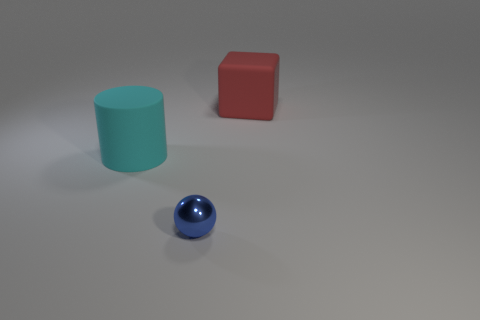Add 3 purple rubber cylinders. How many objects exist? 6 Subtract all cylinders. How many objects are left? 2 Subtract 1 cyan cylinders. How many objects are left? 2 Subtract all big rubber blocks. Subtract all red cubes. How many objects are left? 1 Add 1 cylinders. How many cylinders are left? 2 Add 1 cyan rubber things. How many cyan rubber things exist? 2 